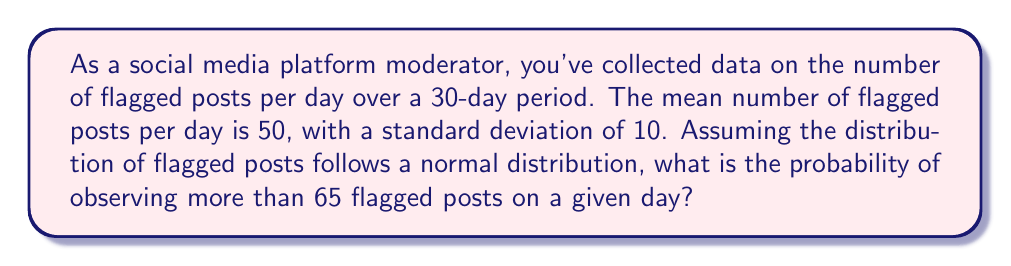Can you solve this math problem? To solve this problem, we'll use the properties of the normal distribution and the concept of z-scores.

1. Given information:
   - Mean (μ) = 50 flagged posts per day
   - Standard deviation (σ) = 10 flagged posts per day
   - We want to find P(X > 65), where X is the number of flagged posts

2. Calculate the z-score for 65 flagged posts:
   $$ z = \frac{x - \mu}{\sigma} = \frac{65 - 50}{10} = 1.5 $$

3. The probability we're looking for is the area under the standard normal curve to the right of z = 1.5.

4. Using a standard normal table or calculator, we can find:
   $$ P(Z > 1.5) = 1 - P(Z \leq 1.5) = 1 - 0.9332 = 0.0668 $$

5. Convert to a percentage:
   0.0668 * 100 = 6.68%

Therefore, the probability of observing more than 65 flagged posts on a given day is approximately 6.68%.
Answer: 6.68% 